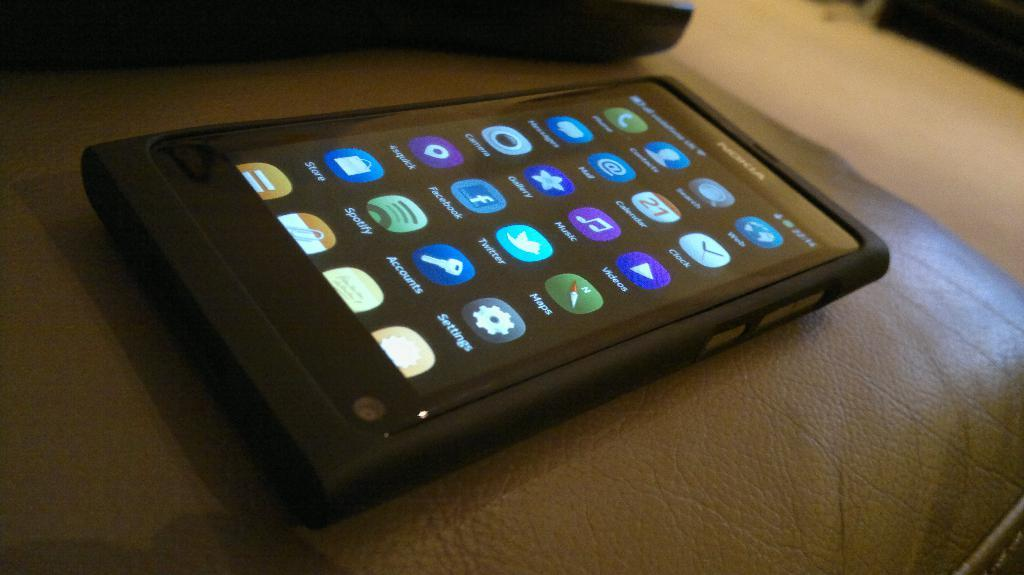<image>
Summarize the visual content of the image. An iphone with a facebook icon visible on the screen 